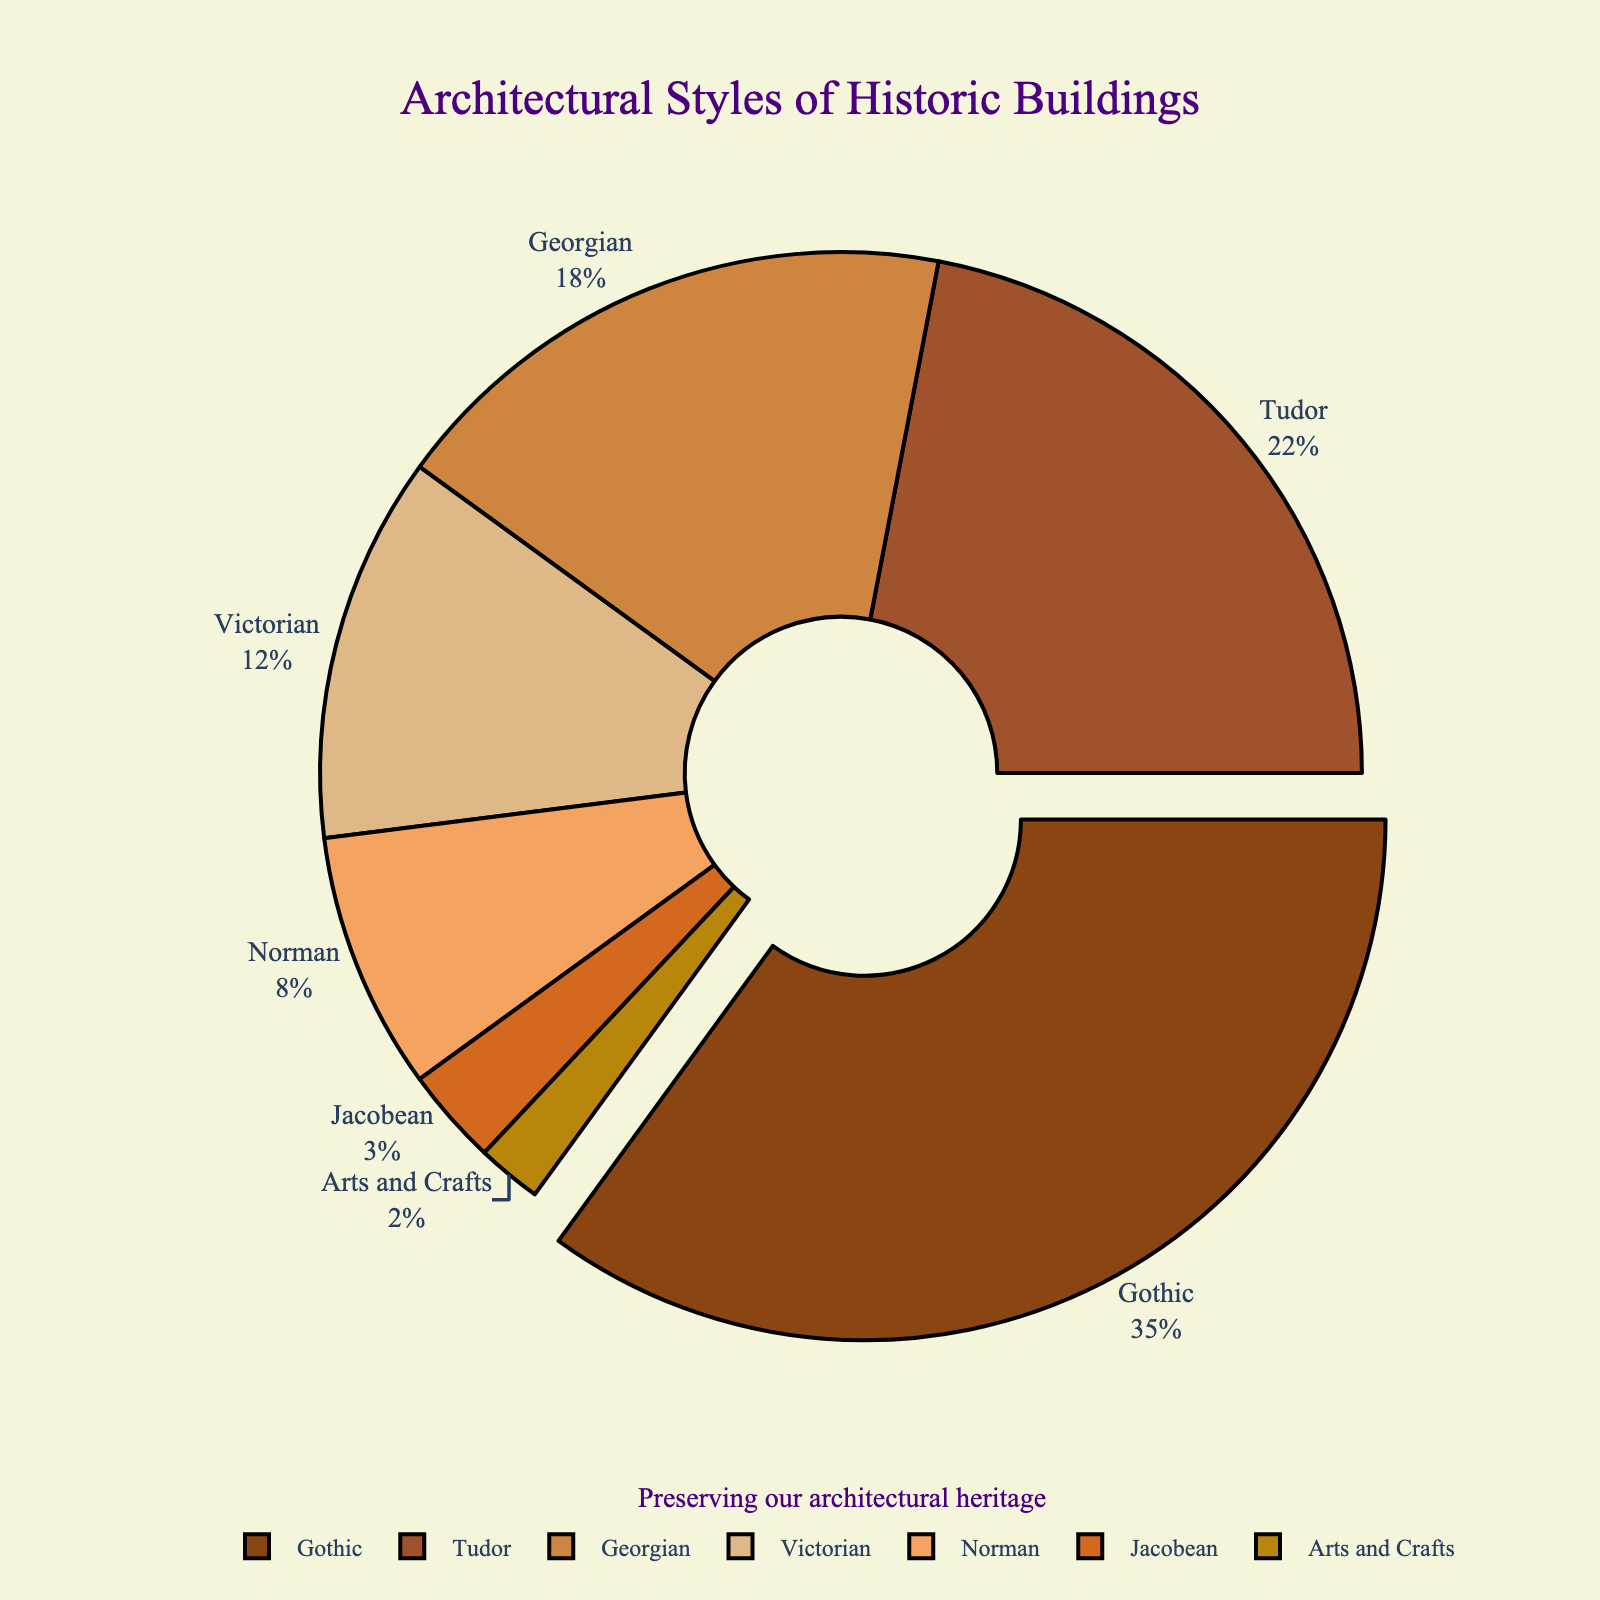What is the most common architectural style among the historic buildings? The figure shows the proportions of different architectural styles. Gothic has the largest segment.
Answer: Gothic Which architectural style has a proportion that is more than twice that of Norman? Check the percentage for Norman, which is 8%. Gothic (35%) and Tudor (22%) are more than double (8% x 2 = 16%).
Answer: Gothic, Tudor How much more common is Gothic compared to Victorian? Comparing the percentages: Gothic is 35%, and Victorian is 12%. The difference is 35% - 12%.
Answer: 23% If you combine the proportions of Georgian and Victorian styles, what is their total percentage? Add Georgian (18%) and Victorian (12%) percentages together: 18% + 12%.
Answer: 30% Which architectural style is represented by the smallest segment in the pie chart? Look at the smallest segment in the pie chart, which corresponds to Arts and Crafts (2%).
Answer: Arts and Crafts Is the proportion of Tudor greater than the combined total of Norman and Jacobean? Check the percentages: Tudor is 22%, Norman is 8%, and Jacobean is 3%. Combined total of Norman and Jacobean is 8% + 3% = 11%. 22% > 11%.
Answer: Yes What is the range of the percentages shown in the pie chart? Take the highest percentage, Gothic (35%), and the lowest, Arts and Crafts (2%), and find the difference: 35% - 2%.
Answer: 33% What proportion of historic buildings have either Gothic or Arts and Crafts styles? Add the percentages for Gothic (35%) and Arts and Crafts (2%) together: 35% + 2%.
Answer: 37% By how much does the Georgian style exceed the Norman style in percentage? Subtract the Norman percentage (8%) from the Georgian percentage (18%): 18% - 8%.
Answer: 10% 